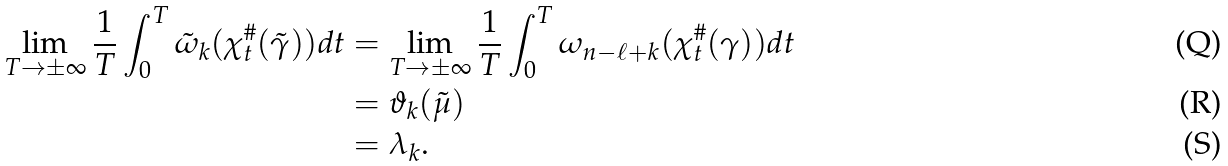<formula> <loc_0><loc_0><loc_500><loc_500>\lim _ { T \to \pm \infty } \frac { 1 } { T } \int _ { 0 } ^ { T } \tilde { \omega } _ { k } ( \chi _ { t } ^ { \# } ( \tilde { \gamma } ) ) d t & = \lim _ { T \to \pm \infty } \frac { 1 } { T } \int _ { 0 } ^ { T } \omega _ { n - \ell + k } ( \chi _ { t } ^ { \# } ( \gamma ) ) d t \\ & = \vartheta _ { k } ( \tilde { \mu } ) \\ & = \lambda _ { k } .</formula> 